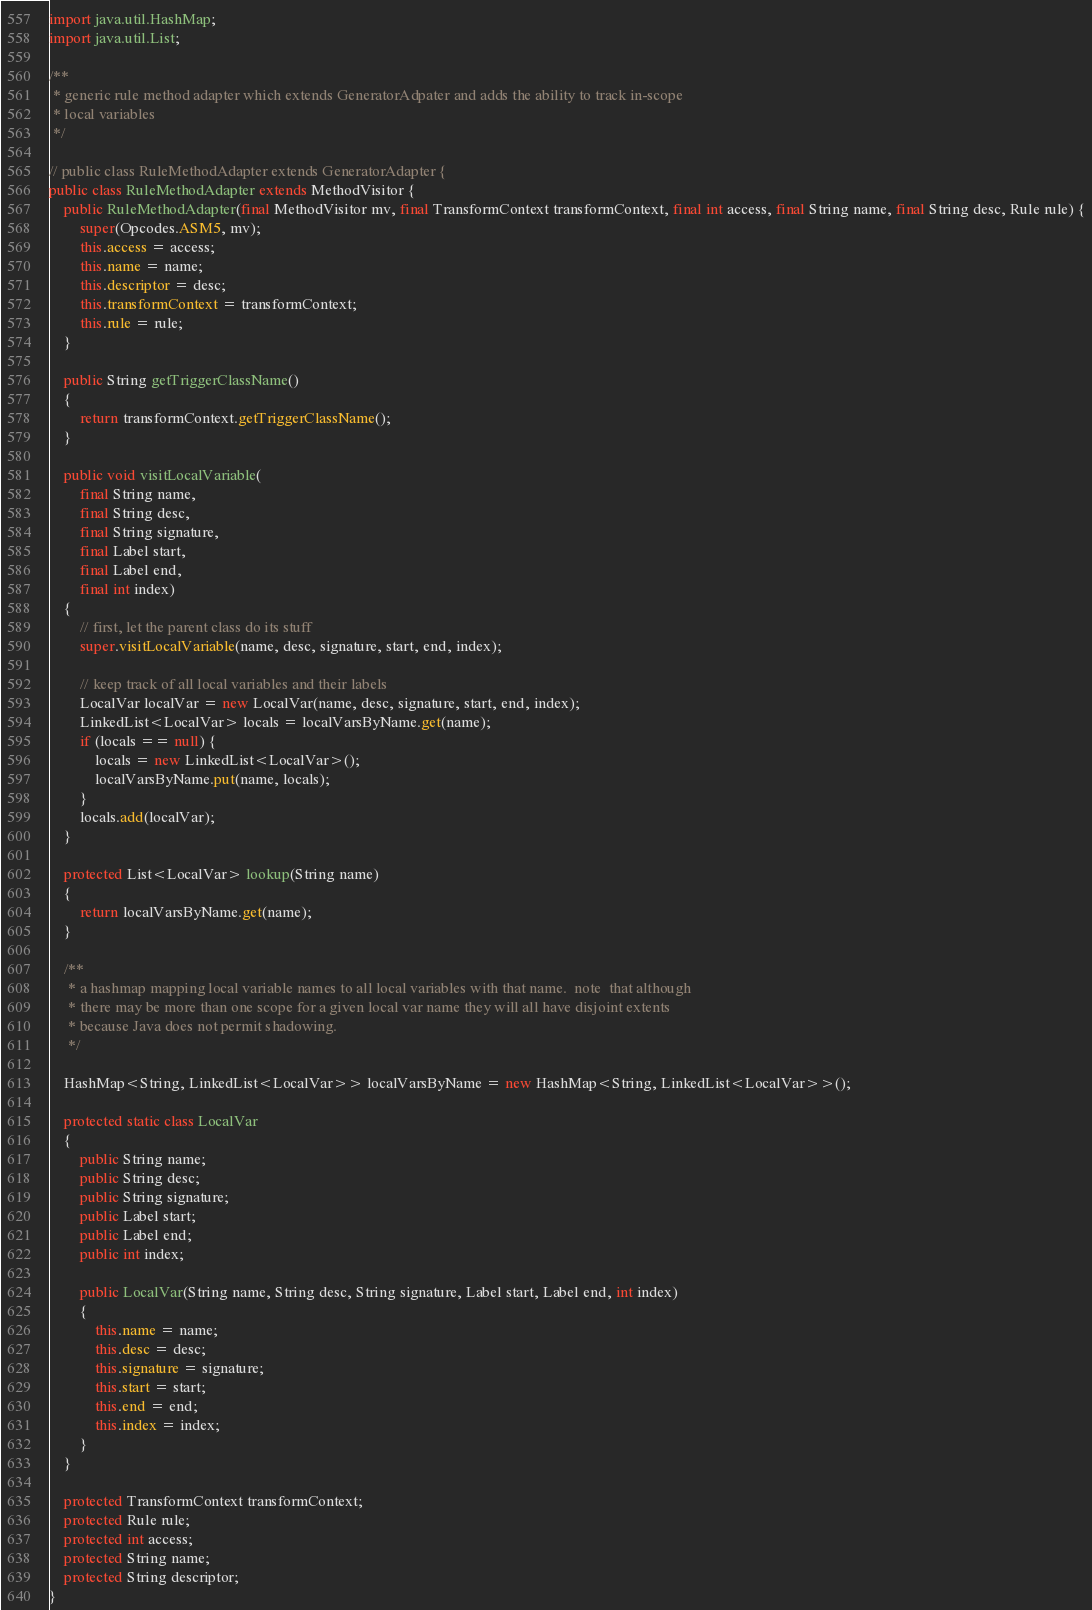<code> <loc_0><loc_0><loc_500><loc_500><_Java_>import java.util.HashMap;
import java.util.List;

/**
 * generic rule method adapter which extends GeneratorAdpater and adds the ability to track in-scope
 * local variables
 */

// public class RuleMethodAdapter extends GeneratorAdapter {
public class RuleMethodAdapter extends MethodVisitor {
    public RuleMethodAdapter(final MethodVisitor mv, final TransformContext transformContext, final int access, final String name, final String desc, Rule rule) {
        super(Opcodes.ASM5, mv);
        this.access = access;
        this.name = name;
        this.descriptor = desc;
        this.transformContext = transformContext;
        this.rule = rule;
    }

    public String getTriggerClassName()
    {
        return transformContext.getTriggerClassName();
    }

    public void visitLocalVariable(
        final String name,
        final String desc,
        final String signature,
        final Label start,
        final Label end,
        final int index)
    {
        // first, let the parent class do its stuff
        super.visitLocalVariable(name, desc, signature, start, end, index);

        // keep track of all local variables and their labels
        LocalVar localVar = new LocalVar(name, desc, signature, start, end, index);
        LinkedList<LocalVar> locals = localVarsByName.get(name);
        if (locals == null) {
            locals = new LinkedList<LocalVar>();
            localVarsByName.put(name, locals);
        }
        locals.add(localVar);
    }

    protected List<LocalVar> lookup(String name)
    {
        return localVarsByName.get(name);
    }

    /**
     * a hashmap mapping local variable names to all local variables with that name.  note  that although
     * there may be more than one scope for a given local var name they will all have disjoint extents
     * because Java does not permit shadowing.
     */

    HashMap<String, LinkedList<LocalVar>> localVarsByName = new HashMap<String, LinkedList<LocalVar>>();

    protected static class LocalVar
    {
        public String name;
        public String desc;
        public String signature;
        public Label start;
        public Label end;
        public int index;

        public LocalVar(String name, String desc, String signature, Label start, Label end, int index)
        {
            this.name = name;
            this.desc = desc;
            this.signature = signature;
            this.start = start;
            this.end = end;
            this.index = index;
        }
    }

    protected TransformContext transformContext;
    protected Rule rule;
    protected int access;
    protected String name;
    protected String descriptor;
}
</code> 